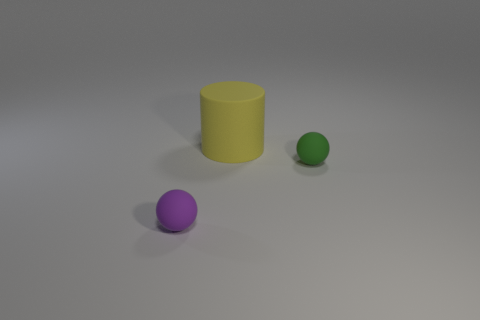The sphere that is on the right side of the sphere that is left of the tiny green ball is what color?
Offer a terse response. Green. There is a object that is both to the left of the tiny green ball and behind the small purple rubber ball; what is it made of?
Offer a very short reply. Rubber. Is there a purple object of the same shape as the tiny green rubber thing?
Give a very brief answer. Yes. There is a tiny rubber object that is on the right side of the tiny purple matte thing; does it have the same shape as the tiny purple rubber object?
Give a very brief answer. Yes. How many objects are in front of the large yellow rubber cylinder and on the left side of the green sphere?
Offer a very short reply. 1. There is a small thing that is on the left side of the tiny green ball; what is its shape?
Your answer should be very brief. Sphere. How many big yellow cylinders are made of the same material as the yellow thing?
Offer a very short reply. 0. Does the green rubber thing have the same shape as the matte thing in front of the small green matte sphere?
Your answer should be very brief. Yes. There is a tiny matte ball on the right side of the tiny thing that is to the left of the cylinder; are there any small matte balls that are in front of it?
Provide a succinct answer. Yes. There is a sphere left of the green matte ball; what size is it?
Your answer should be very brief. Small. 